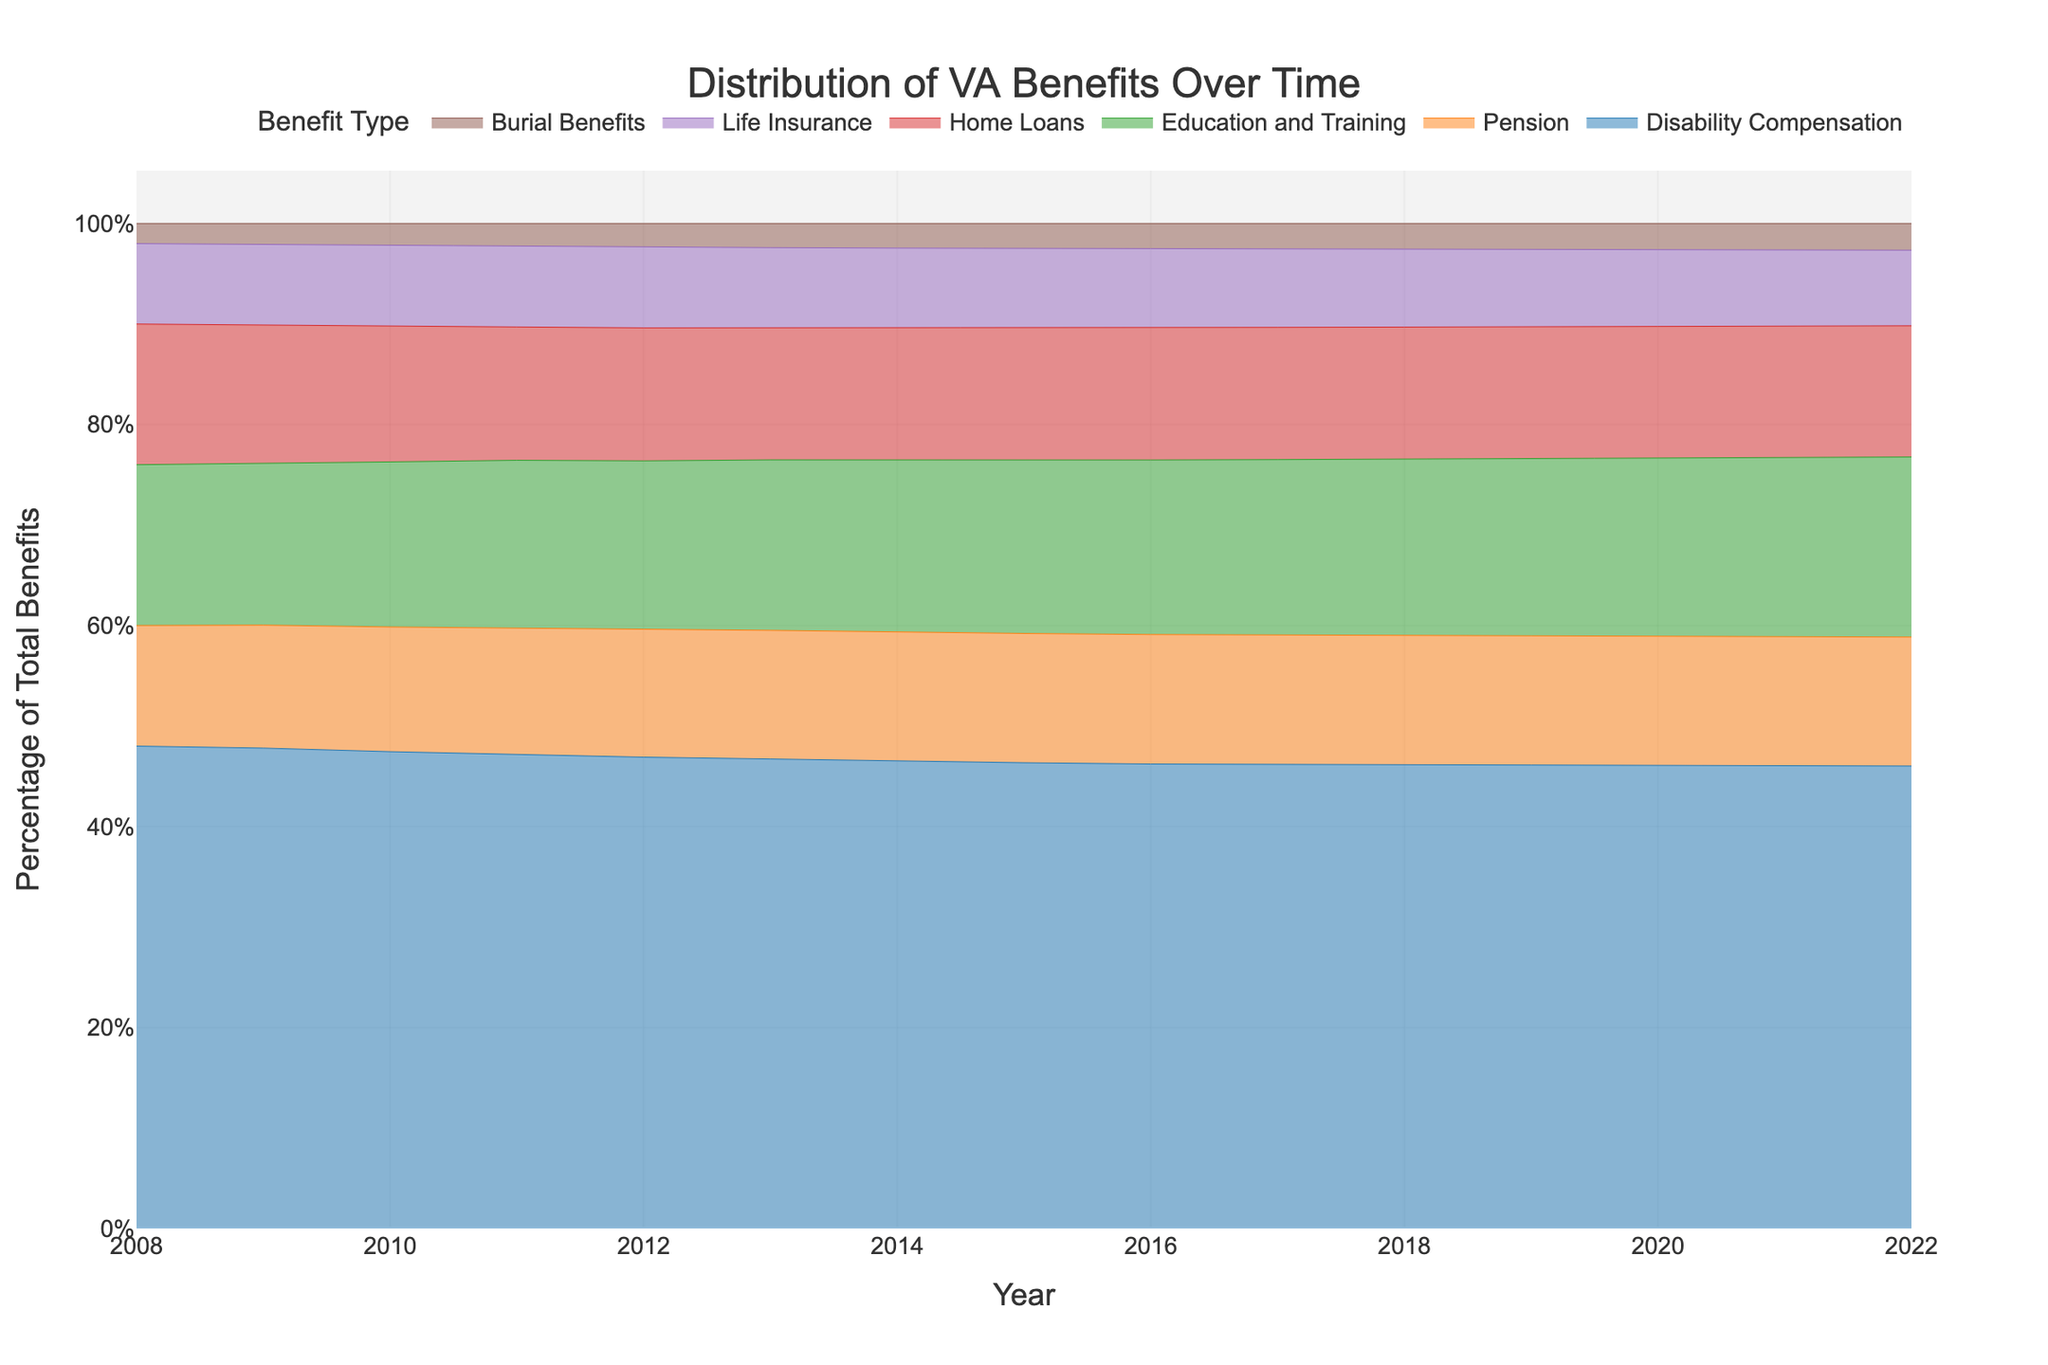what is the title of the graph? The title of the graph is usually prominently displayed at the top of the figure. It helps viewers quickly understand what the graph is about. Here, it reads "Distribution of VA Benefits Over Time".
Answer: Distribution of VA Benefits Over Time What are the six benefits types shown in the graph? The benefit types are usually labeled in the legend of the graph. In this case, the benefits shown are Disability Compensation, Pension, Education and Training, Home Loans, Life Insurance, and Burial Benefits.
Answer: Disability Compensation, Pension, Education and Training, Home Loans, Life Insurance, Burial Benefits Which benefit type shows the largest increase in percentage over time? To determine this, you need to compare the change in the sizes of the areas associated with each benefit type over the years. Disability Compensation shows the largest increase, as its area grows substantially over time.
Answer: Disability Compensation In what year was the percentage of Education and Training benefits higher: in 2010 or 2022? To find this, compare the width of the area representing Education and Training benefits for the years 2010 and 2022. The width is wider in 2022, indicating a higher percentage.
Answer: 2022 Which year had the least percentage for Life Insurance benefits, and how do you know? To identify this year, look at the narrowest width for the Life Insurance benefits area on the x-axis. The narrowest width occurs in 2008.
Answer: 2008 Can you rank the benefits from highest to lowest percentage in the year 2022? To rank the benefits, compare the widths of each benefit area in the year 2022. The order from highest to lowest is: Disability Compensation, Education and Training, Pension, Home Loans, Life Insurance, Burial Benefits.
Answer: Disability Compensation, Education and Training, Pension, Home Loans, Life Insurance, Burial Benefits How did the percentage distribution of Pension benefits change from 2008 to 2018? To observe this, compare the heights of the Pension benefit areas at the years 2008 and 2018. The percentage appears to increase gradually over the 10 years.
Answer: Increased gradually Which benefit type had the smallest fluctuation in percentage over the 15-year period? Look for the benefit whose area maintains a consistent width throughout the years. Burial Benefits has the smallest fluctuation and remains relatively stable.
Answer: Burial Benefits By how much did the percentage of Home Loans benefits increase from 2008 to 2022? To determine the increase, observe the width of the Home Loans area in 2008 and 2022. The percentage segment appears to increase gradually, reflecting an overall upward trend.
Answer: Increased gradually 